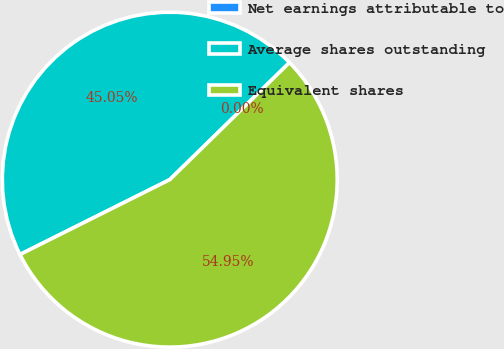Convert chart to OTSL. <chart><loc_0><loc_0><loc_500><loc_500><pie_chart><fcel>Net earnings attributable to<fcel>Average shares outstanding<fcel>Equivalent shares<nl><fcel>0.0%<fcel>45.05%<fcel>54.95%<nl></chart> 